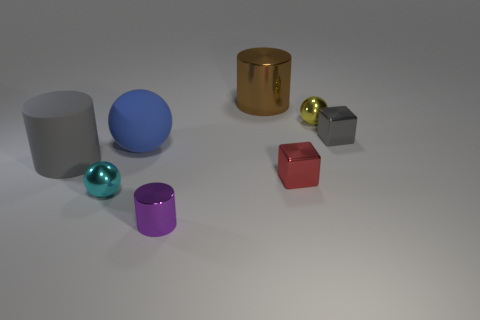Subtract all small metal balls. How many balls are left? 1 Subtract all red cubes. How many cubes are left? 1 Add 2 brown balls. How many objects exist? 10 Subtract 1 balls. How many balls are left? 2 Subtract all purple cylinders. How many blue spheres are left? 1 Subtract all red objects. Subtract all yellow spheres. How many objects are left? 6 Add 3 gray things. How many gray things are left? 5 Add 7 yellow things. How many yellow things exist? 8 Subtract 0 blue cylinders. How many objects are left? 8 Subtract all cylinders. How many objects are left? 5 